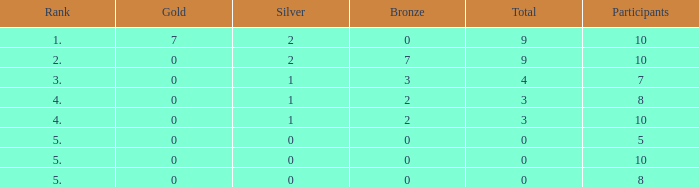What's the total Rank that has a Gold that's smaller than 0? None. 